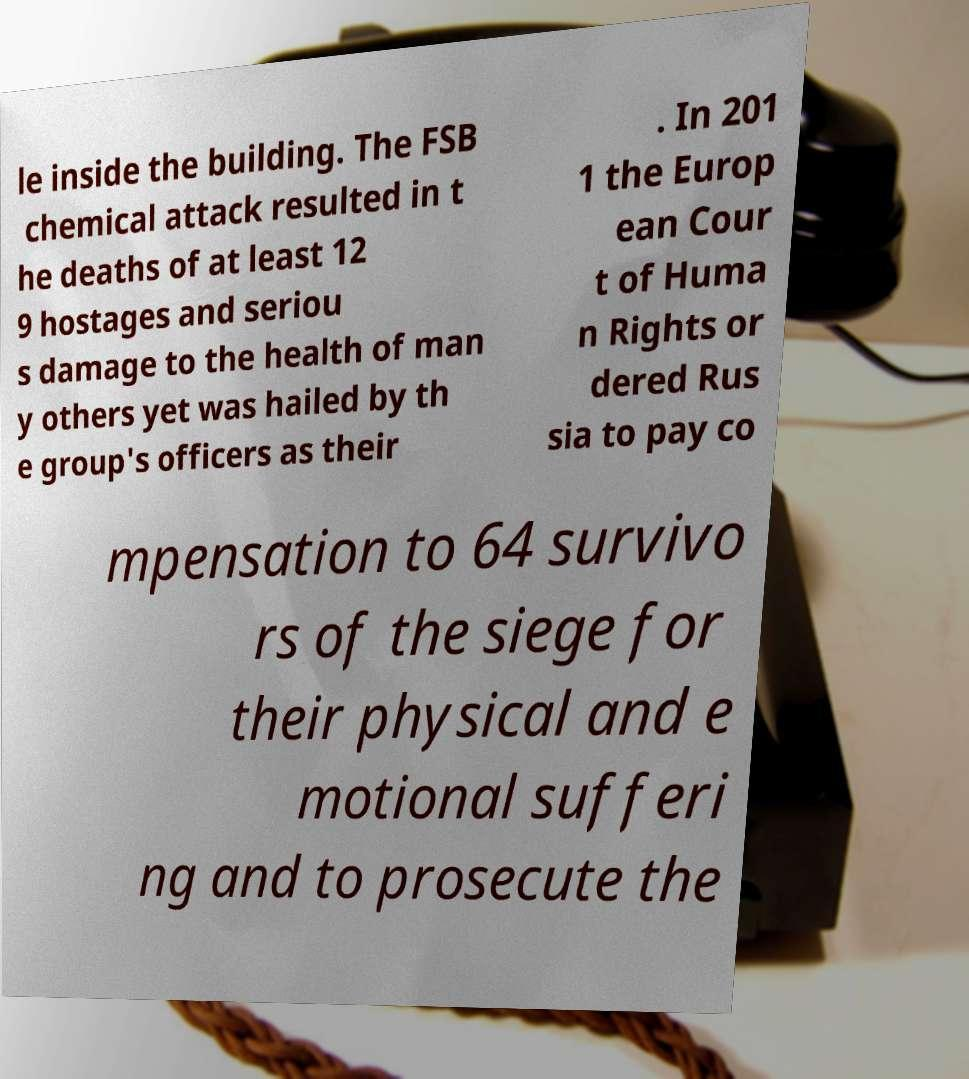Please identify and transcribe the text found in this image. le inside the building. The FSB chemical attack resulted in t he deaths of at least 12 9 hostages and seriou s damage to the health of man y others yet was hailed by th e group's officers as their . In 201 1 the Europ ean Cour t of Huma n Rights or dered Rus sia to pay co mpensation to 64 survivo rs of the siege for their physical and e motional sufferi ng and to prosecute the 